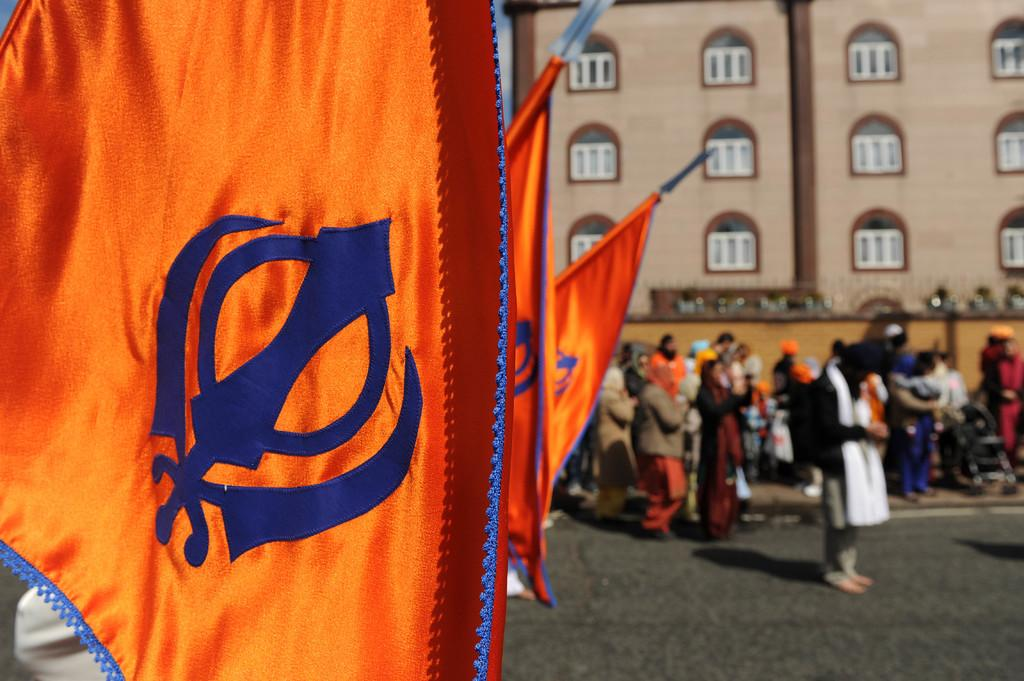What is located on the left side of the image? A: There are three flags on the left side of the image. What can be seen in the foreground of the image? There are people standing beside the road in the image. What type of structure is visible in the background of the image? There is a tall building visible in the background of the image. How many pigs are visible in the image? There are no pigs present in the image. What direction are the people looking in the image? The facts provided do not mention the direction the people are looking, so we cannot determine that from the image. 